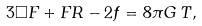<formula> <loc_0><loc_0><loc_500><loc_500>3 \square F + F R - 2 f = 8 \pi G \, T ,</formula> 